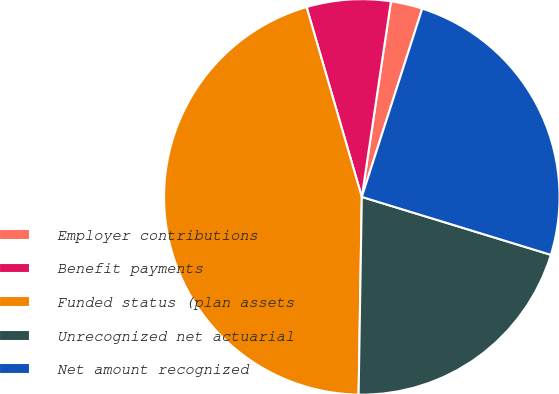<chart> <loc_0><loc_0><loc_500><loc_500><pie_chart><fcel>Employer contributions<fcel>Benefit payments<fcel>Funded status (plan assets<fcel>Unrecognized net actuarial<fcel>Net amount recognized<nl><fcel>2.59%<fcel>6.86%<fcel>45.24%<fcel>20.53%<fcel>24.79%<nl></chart> 